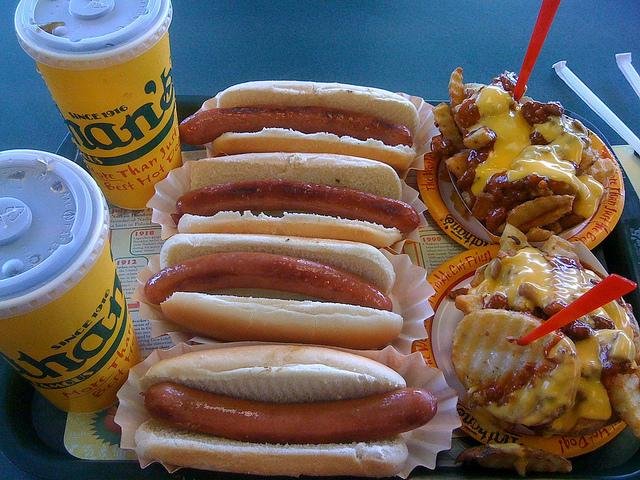What annual event is the company famous for? eating contest 